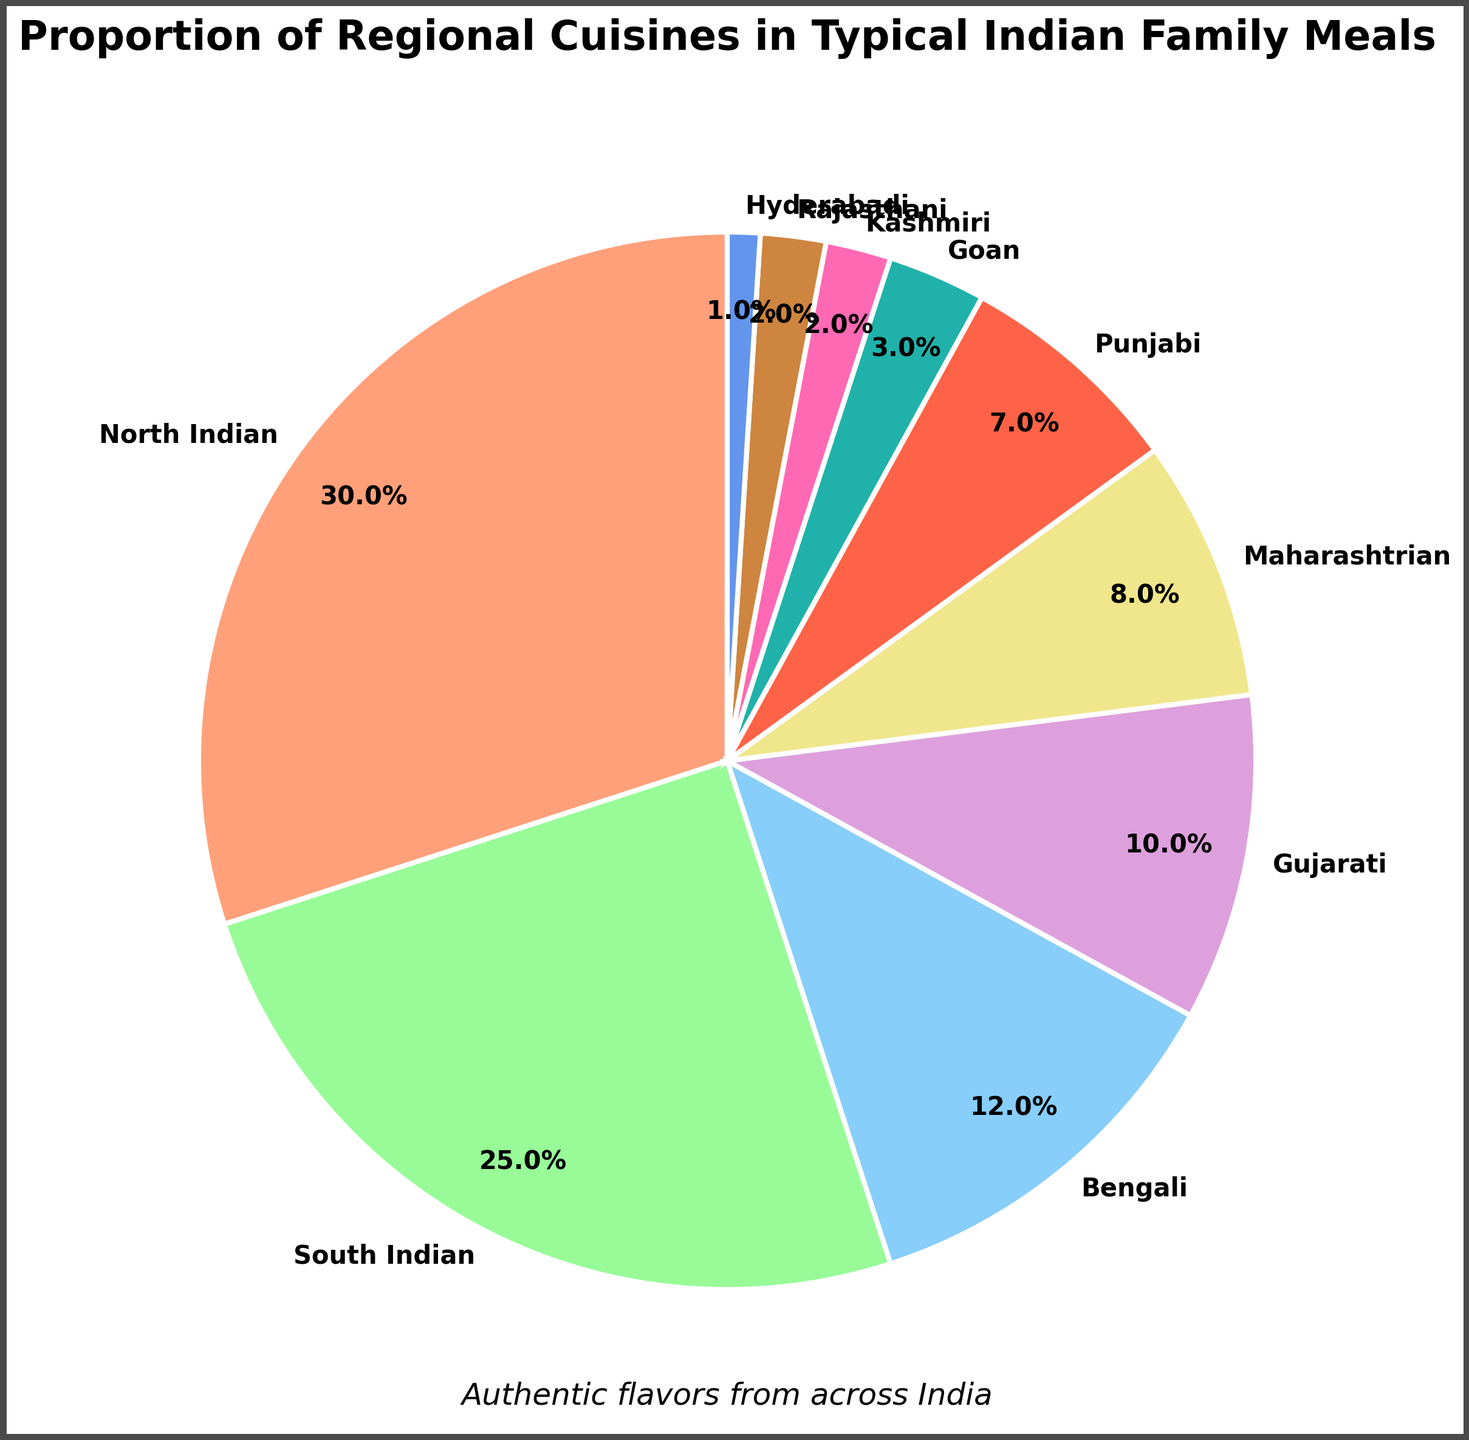What is the highest represented cuisine in the pie chart? The pie chart shows multiple sections with labels and percentages. The largest section visually represents the North Indian cuisine, with 30%.
Answer: North Indian How much more popular is North Indian cuisine compared to Bengali cuisine? North Indian cuisine is represented with 30% and Bengali cuisine with 12%. Subtracting 12 from 30 gives 18.
Answer: 18% Which two cuisines have the smallest representation? The pie chart shows Hyderabadi with 1% and Kashmiri and Rajasthani each with 2%. Since we need the two smallest, it's Hyderabadi and one of either Kashmiri or Rajasthani.
Answer: Hyderabadi and Kashmiri (or Rajasthani) What is the combined percentage of South Indian and Gujarati cuisines? South Indian cuisine is represented with 25% and Gujarati cuisine with 10%. Adding these up gives 25 + 10 = 35.
Answer: 35% Which cuisines have a representation of more than 10%? By looking at the pie chart, North Indian (30%), South Indian (25%), and Bengali (12%) all exceed 10%.
Answer: North Indian, South Indian, Bengali Are there more North Indian or South Indian meals represented in the chart? North Indian cuisine is 30%, while South Indian cuisine is 25%. Since 30% is greater than 25%, North Indian has more representation.
Answer: North Indian Which cuisine is represented by pink color, and what is its percentage? By identifying the color pink on the pie chart and matching it to its label, we see it represents Goan cuisine with 3%.
Answer: Goan, 3% What proportion of meals is represented by Maharashtrian and Punjabi cuisines combined? Maharashtrian cuisine is 8% and Punjabi cuisine is 7%. Adding these gives 8 + 7 = 15.
Answer: 15% What is the percentage difference between the least and most represented cuisines? The least represented cuisine is Hyderabadi with 1%, and the most represented is North Indian with 30%. Subtracting these gives 30 - 1 = 29.
Answer: 29% 